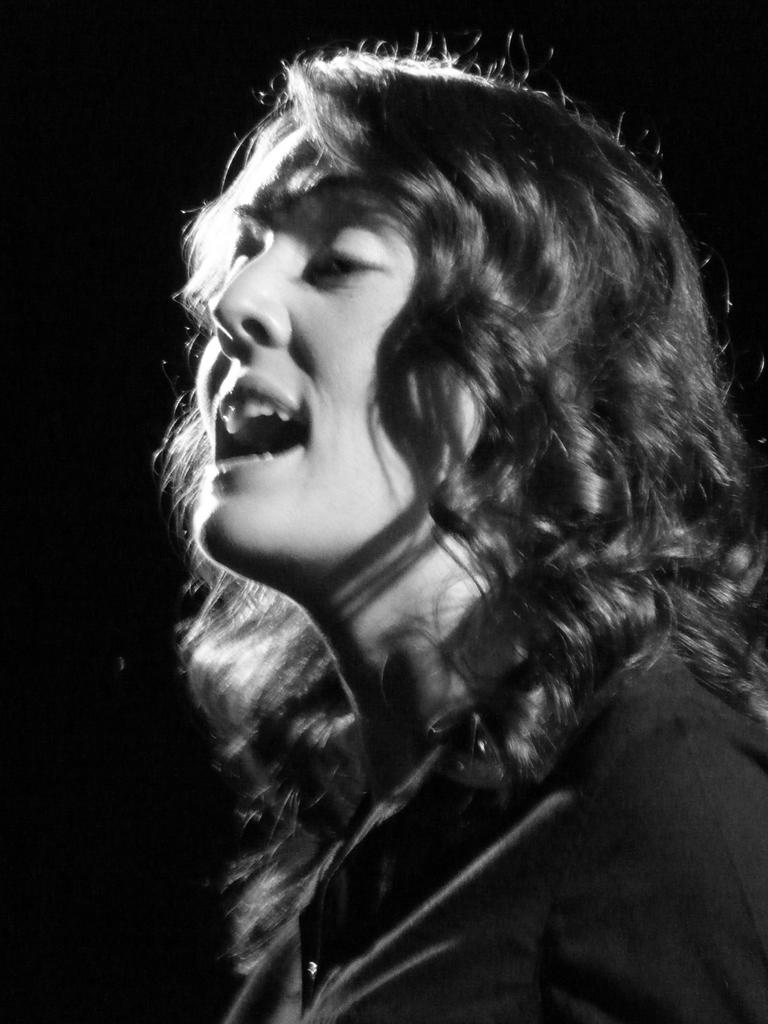Who is present in the image? There is a woman in the image. What can be observed about the background of the image? The background of the image is dark. What type of railway is visible in the image? There is no railway present in the image; it only features a woman and a dark background. 